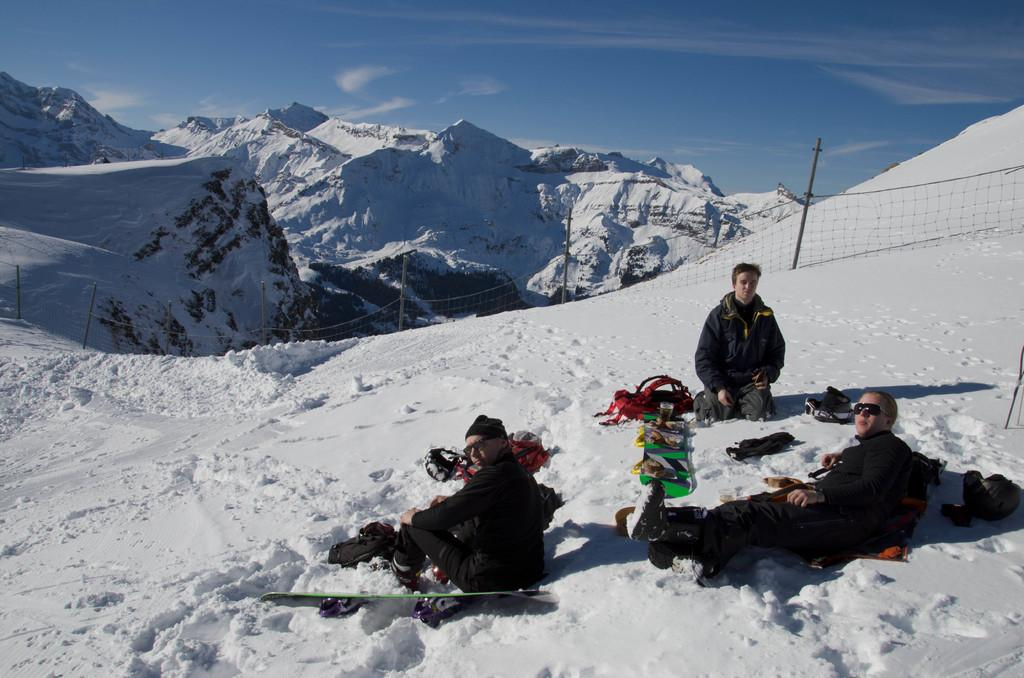What are the people in the image doing? The people in the image are sitting on the snow. What equipment is visible in the image? Ski boards are present in the image. What can be seen in the background of the image? There are hills, a fence, and the sky visible in the background of the image. What is the ground made of in the image? There is snow in the image. What type of trains can be seen passing by in the image? There are no trains present in the image; it features people sitting on the snow with ski boards. Is there a carpenter working on a project in the image? There is no carpenter or any project visible in the image. 